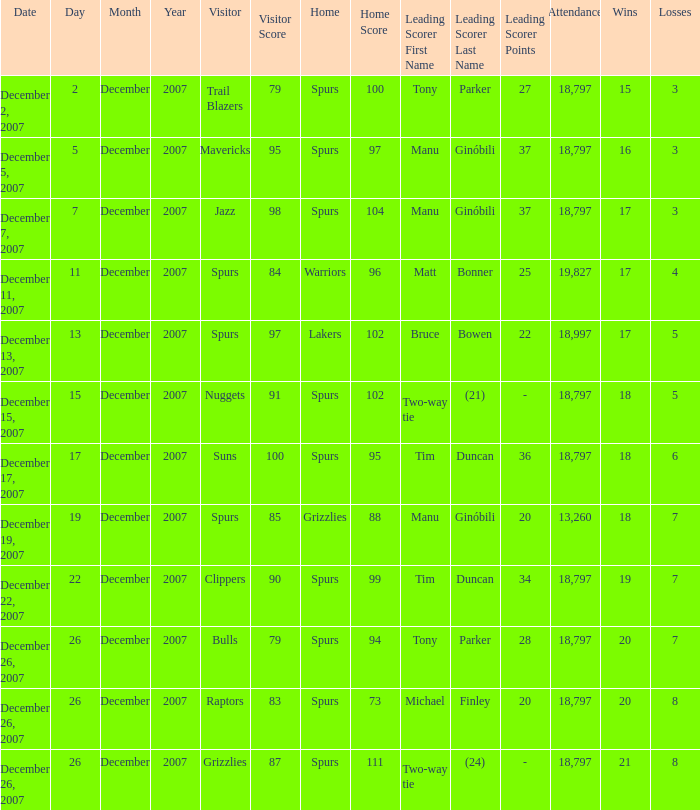What is the record of the game on December 5, 2007? 16–3. 